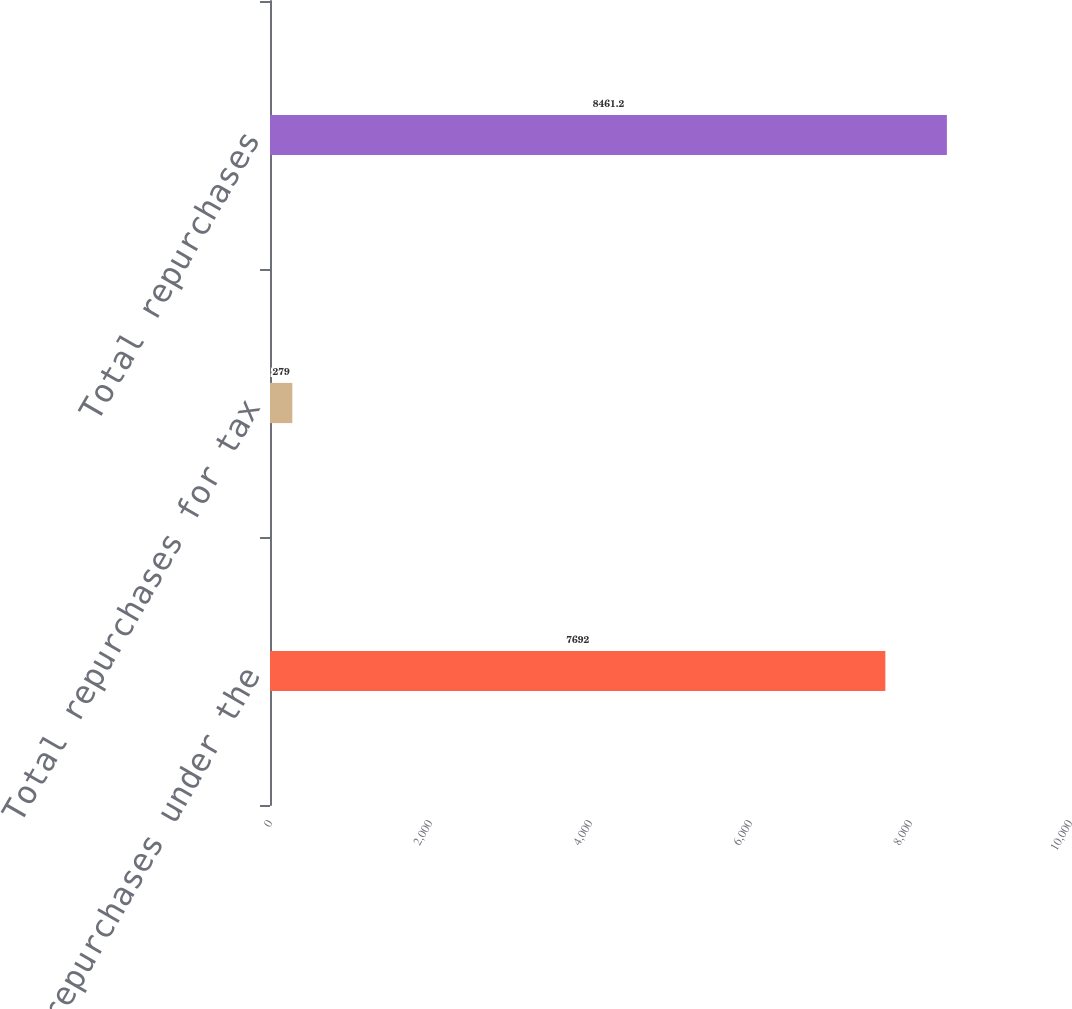<chart> <loc_0><loc_0><loc_500><loc_500><bar_chart><fcel>Total repurchases under the<fcel>Total repurchases for tax<fcel>Total repurchases<nl><fcel>7692<fcel>279<fcel>8461.2<nl></chart> 